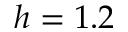Convert formula to latex. <formula><loc_0><loc_0><loc_500><loc_500>h = 1 . 2</formula> 